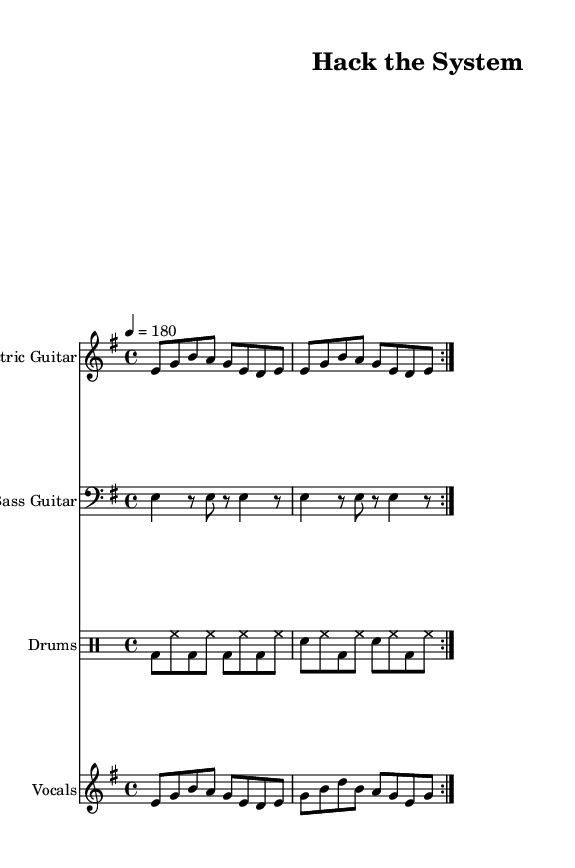What is the key signature of this music? The key signature appears at the beginning of the staff and indicates E minor, which is represented by one sharp (F#).
Answer: E minor What is the time signature of this piece? The time signature is indicated at the beginning of the music and is noted as 4/4, meaning there are four beats per measure.
Answer: 4/4 What is the tempo marking for this composition? The tempo marking is stated at the beginning of the score and is indicated as 4 = 180, which means the piece should be played at 180 beats per minute.
Answer: 180 What instruments are featured in this piece? The instruments are listed at the beginning of each staff: Electric Guitar, Bass Guitar, Drums, and Vocals.
Answer: Electric Guitar, Bass Guitar, Drums, Vocals How many times is the main theme repeated in the electric guitar part? The score notation indicates that the electric guitar part repeats twice, as it is marked with a volta indicating repeated sections.
Answer: 2 What lyrical themes are present in the song? The lyrics focus on innovation and hacking culture, as expressed in phrases like "Innovation our desire" and "Hack the system, break it down."
Answer: Innovation and hacking What is the vocal range indicated in the score for this piece? The vocal part is written in the relative pitch that starts from E and goes to G, indicating a melody primarily in the higher range typical of punk vocals.
Answer: E to G 